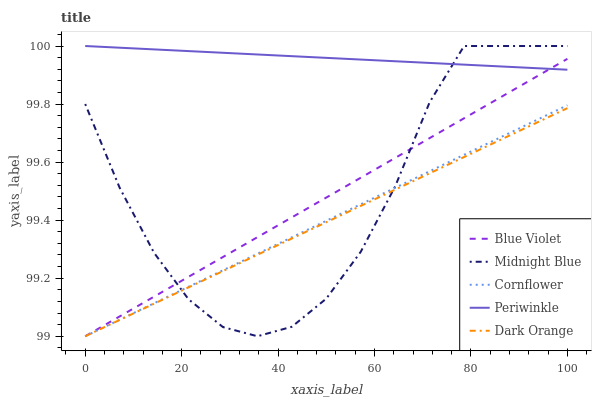Does Dark Orange have the minimum area under the curve?
Answer yes or no. Yes. Does Periwinkle have the maximum area under the curve?
Answer yes or no. Yes. Does Midnight Blue have the minimum area under the curve?
Answer yes or no. No. Does Midnight Blue have the maximum area under the curve?
Answer yes or no. No. Is Periwinkle the smoothest?
Answer yes or no. Yes. Is Midnight Blue the roughest?
Answer yes or no. Yes. Is Midnight Blue the smoothest?
Answer yes or no. No. Is Periwinkle the roughest?
Answer yes or no. No. Does Cornflower have the lowest value?
Answer yes or no. Yes. Does Midnight Blue have the lowest value?
Answer yes or no. No. Does Midnight Blue have the highest value?
Answer yes or no. Yes. Does Blue Violet have the highest value?
Answer yes or no. No. Is Dark Orange less than Periwinkle?
Answer yes or no. Yes. Is Periwinkle greater than Dark Orange?
Answer yes or no. Yes. Does Midnight Blue intersect Dark Orange?
Answer yes or no. Yes. Is Midnight Blue less than Dark Orange?
Answer yes or no. No. Is Midnight Blue greater than Dark Orange?
Answer yes or no. No. Does Dark Orange intersect Periwinkle?
Answer yes or no. No. 